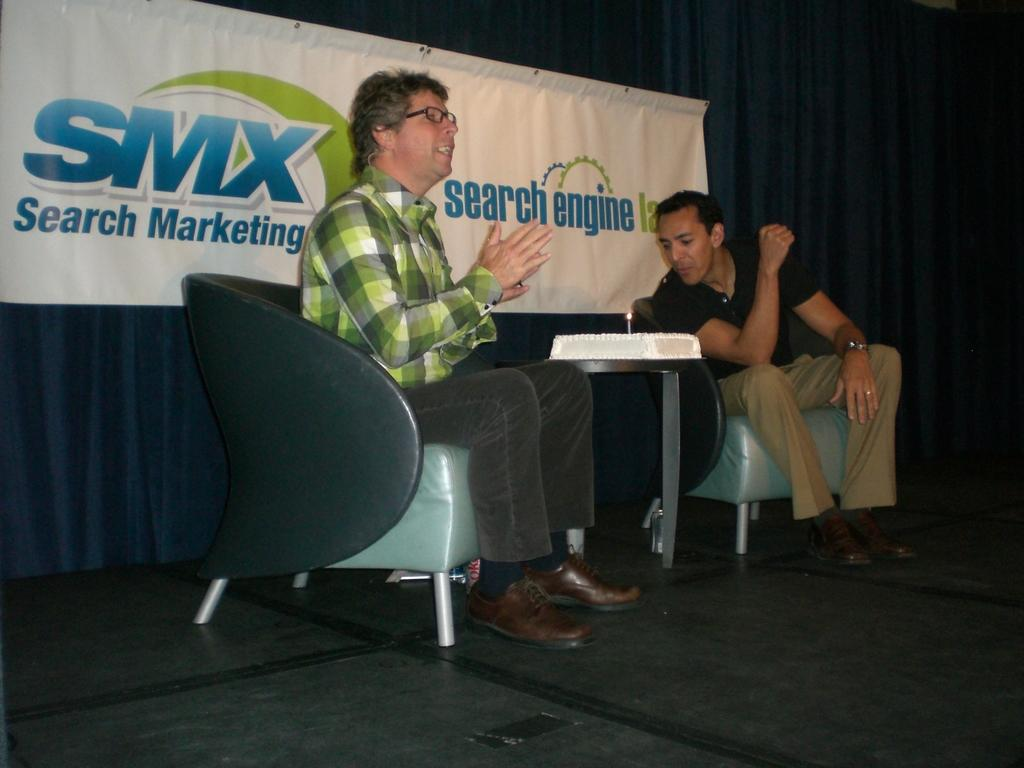How many people are in the image? There are two men in the image. What are the men doing in the image? The men are sitting on chairs and talking to each other. Is there any food visible in the image? Yes, there is a cake on a table in the image. What type of blood is visible on the cake in the image? There is no blood visible on the cake in the image. What songs are the men singing in the image? The men are not singing in the image; they are talking to each other. 